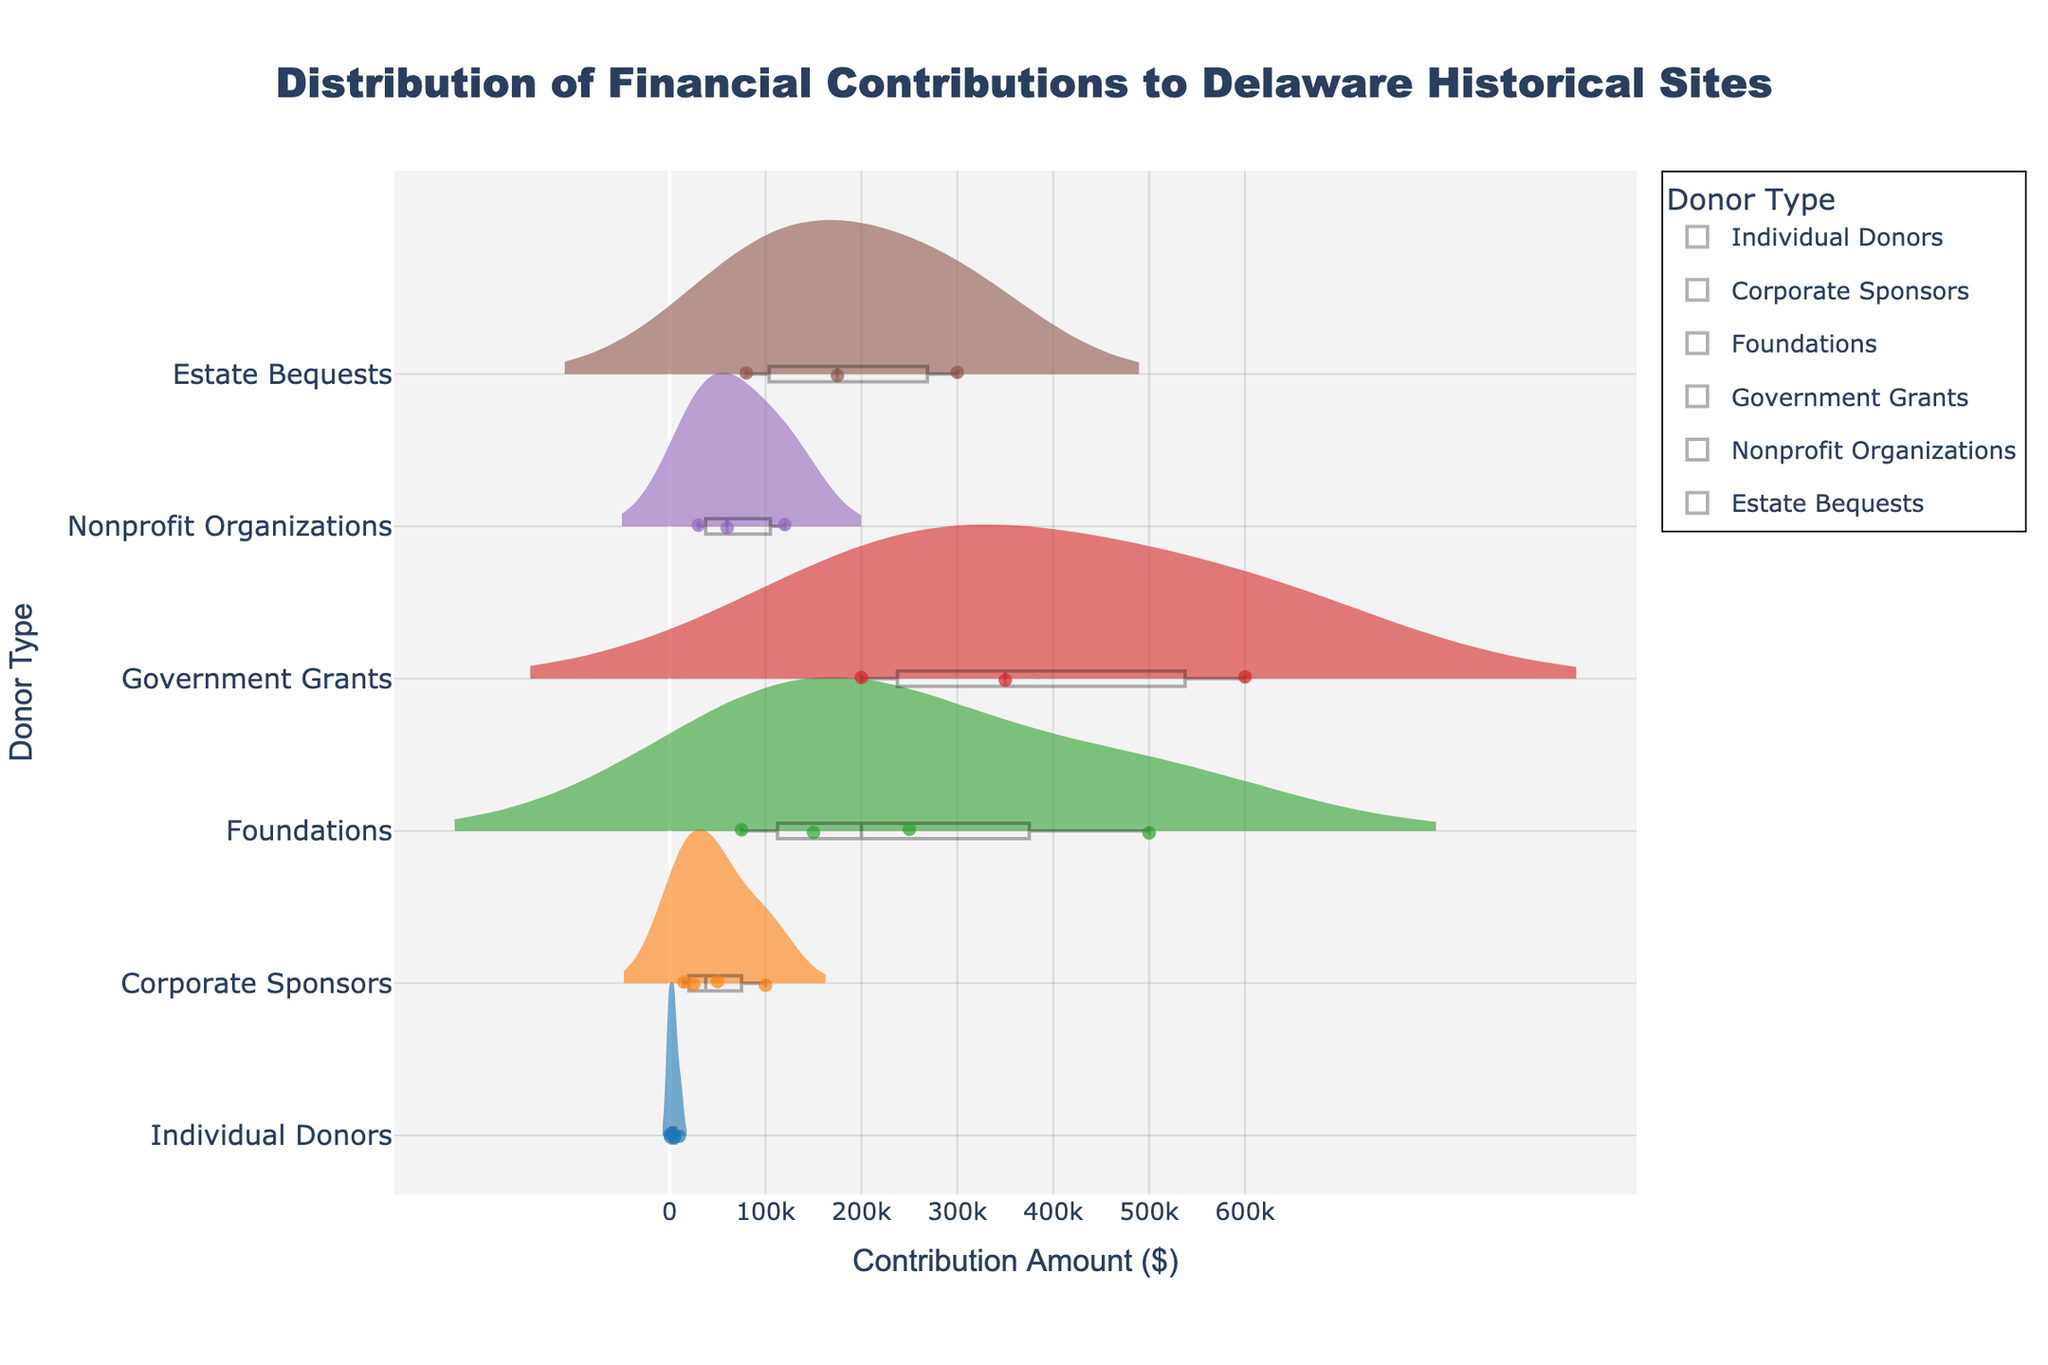What is the title of the figure? The title of the figure is typically displayed at the top of the chart. It provides the context of the data being visualized. In this case, the title directly describes what the visual is about.
Answer: Distribution of Financial Contributions to Delaware Historical Sites Which donor type has the highest contribution amount displayed in the figure? To determine this, look at the horizontal axis and see which donor type has points furthest to the right, indicating the highest contribution amount.
Answer: Government Grants How many distinct donor types are there in the figure? Count the unique labels on the vertical axis. Each label represents a different donor type.
Answer: 6 Which donor type has the most varied contribution amounts? Variation can be determined by the spread of the data points or the width of the violin plot. The wider the spread, the more varied the contributions.
Answer: Foundations What is the median contribution amount for Corporate Sponsors? The box plot inside the violin plot shows the median as the line inside the box. Locate the line for Corporate Sponsors to find the median value.
Answer: 37,500 Compare the average contribution amounts of Individual Donors and Nonprofit Organizations. Which is higher? Calculate the average values by summing the contributions in each group and dividing by the number of contributions. Compare the two results. Individual Donors: (500+1000+2500+5000+10000)/5 = 3800, Nonprofit Organizations: (30000+60000+120000)/3 = 70000. Thus, the average for Nonprofit Organizations is higher.
Answer: Nonprofit Organizations Which donor type has its highest contribution amount around the middle of the distribution compared to the others? Identify the donor type by finding the violin plot where the highest contribution amount is more centered towards the middle instead of the tail.
Answer: Individual Donors What color is used to represent Estate Bequests in the figure? Identify the color by looking at the legend or the colored data points in the violin plot associated with Estate Bequests.
Answer: Brown How does the spread of contributions from Government Grants compare to that from Estate Bequests? Compare the width of the violin plots for Government Grants and Estate Bequests to see which has a larger spread, indicating more variation.
Answer: Government Grants have a wider spread Which donor type has the smallest spread, indicating less variation in their contributions? Find the narrowest violin plot in terms of horizontal spread to identify the donor type with the least variation.
Answer: Individual Donors 